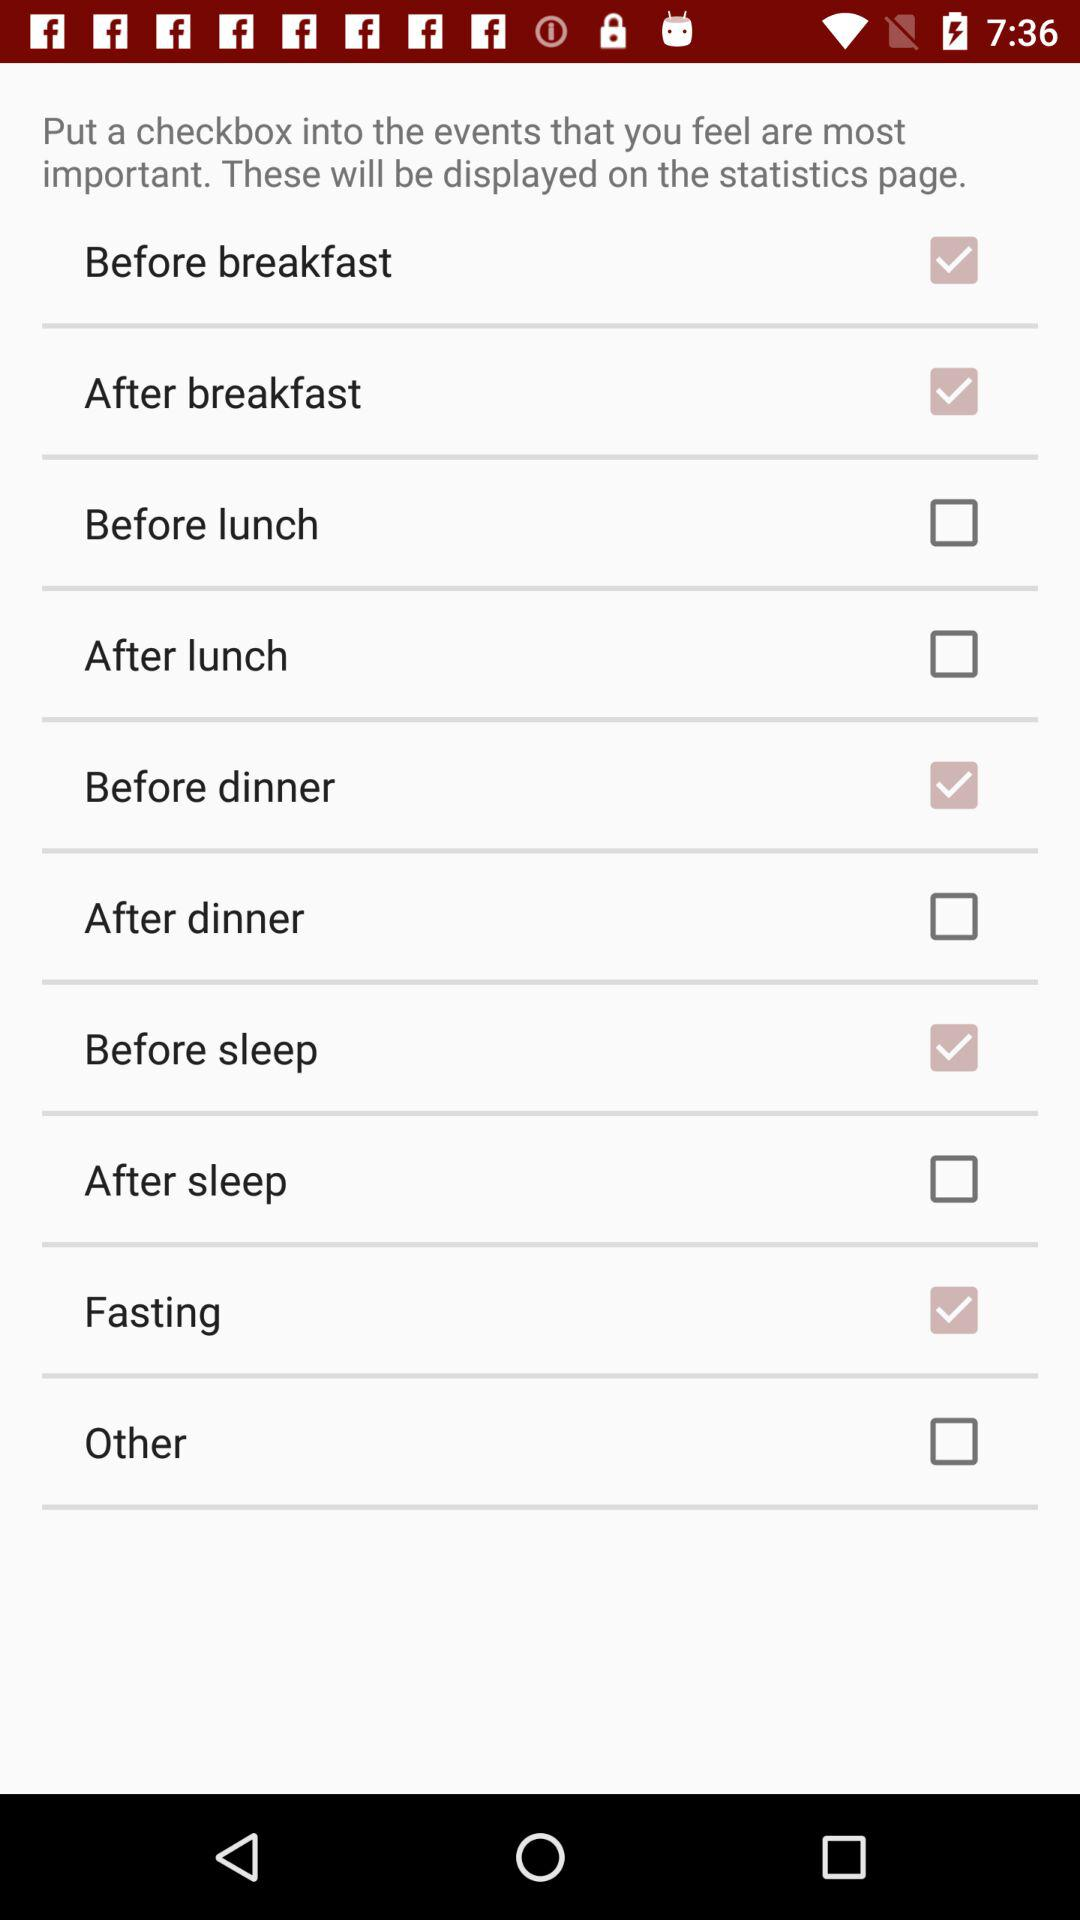What is the status of "Fasting"? The status is "on". 